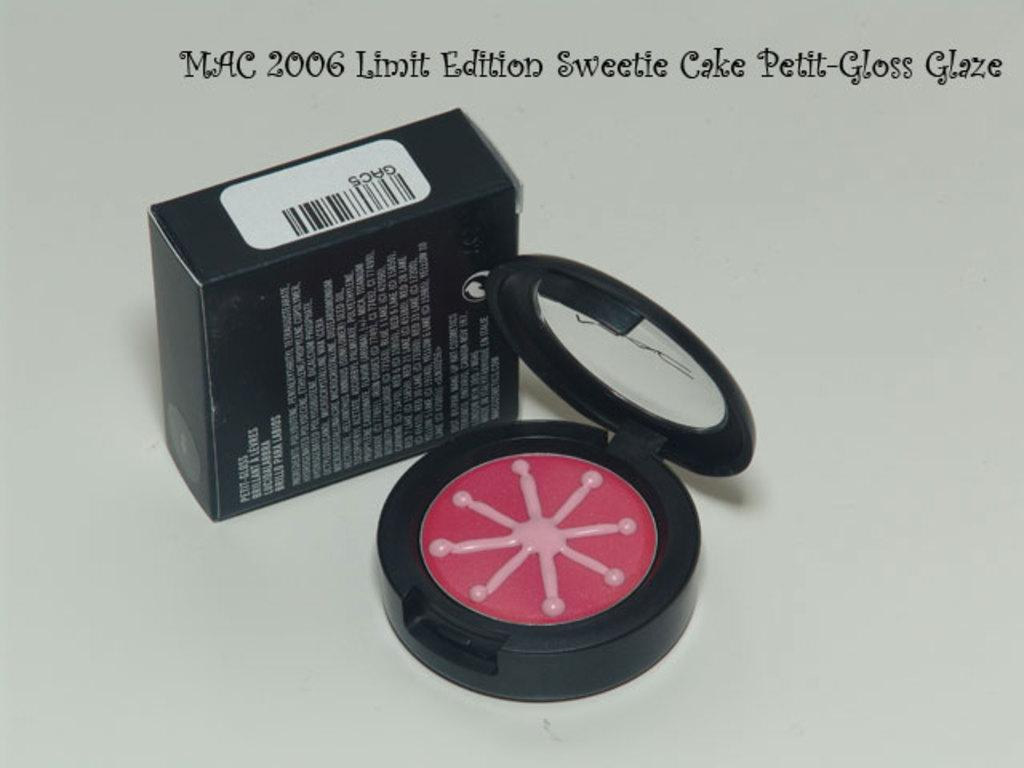<image>
Write a terse but informative summary of the picture. A sweetie cake petit-gloss glaze for women colored red 